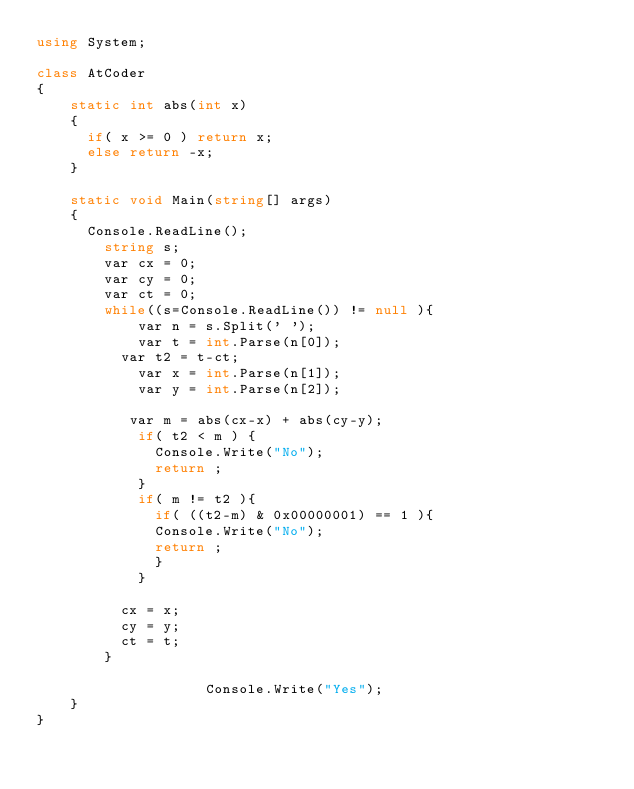<code> <loc_0><loc_0><loc_500><loc_500><_C#_>using System;

class AtCoder
{
  	static int abs(int x)
    {
      if( x >= 0 ) return x;
      else return -x;
    }
  
    static void Main(string[] args)
    {
      Console.ReadLine();
        string s;
      	var cx = 0;
      	var cy = 0;
      	var ct = 0;
      	while((s=Console.ReadLine()) != null ){
        	var n = s.Split(' ');     
          	var t = int.Parse(n[0]);
          var t2 = t-ct;
          	var x = int.Parse(n[1]);
          	var y = int.Parse(n[2]);
          
           var m = abs(cx-x) + abs(cy-y);
          	if( t2 < m ) {
              Console.Write("No");
              return ;
            }
            if( m != t2 ){
              if( ((t2-m) & 0x00000001) == 1 ){
              Console.Write("No");
              return ;                
              }
            }
          
          cx = x;
          cy = y;
          ct = t;
      	}      	
      
                    Console.Write("Yes");
    }
}</code> 